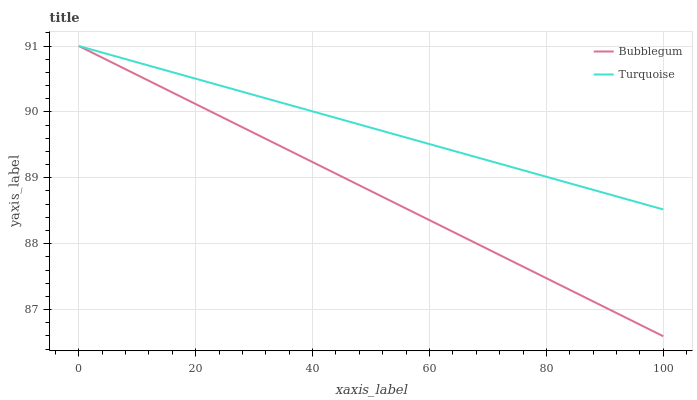Does Bubblegum have the minimum area under the curve?
Answer yes or no. Yes. Does Turquoise have the maximum area under the curve?
Answer yes or no. Yes. Does Bubblegum have the maximum area under the curve?
Answer yes or no. No. Is Bubblegum the smoothest?
Answer yes or no. Yes. Is Turquoise the roughest?
Answer yes or no. Yes. Is Bubblegum the roughest?
Answer yes or no. No. Does Bubblegum have the lowest value?
Answer yes or no. Yes. Does Bubblegum have the highest value?
Answer yes or no. Yes. Does Turquoise intersect Bubblegum?
Answer yes or no. Yes. Is Turquoise less than Bubblegum?
Answer yes or no. No. Is Turquoise greater than Bubblegum?
Answer yes or no. No. 